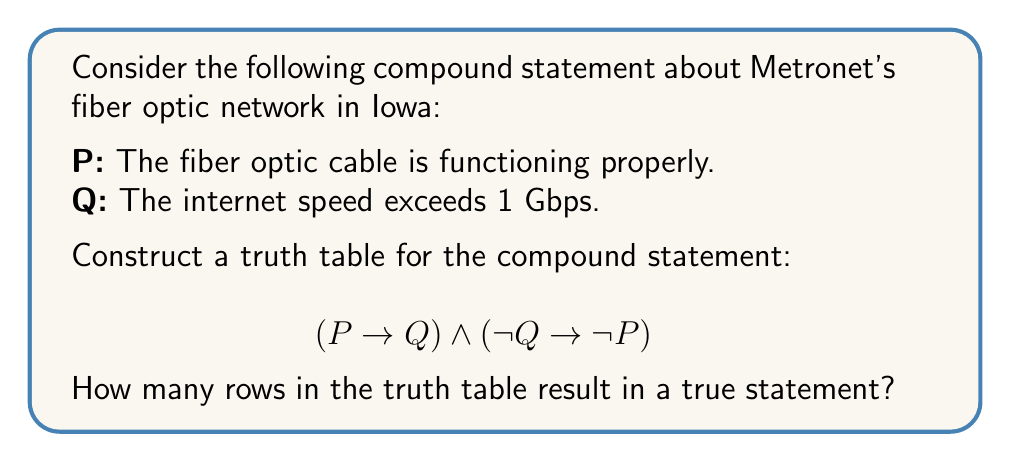Help me with this question. Let's approach this step-by-step:

1) First, we need to construct the truth table. We'll have columns for P, Q, $(P \rightarrow Q)$, $(\lnot Q \rightarrow \lnot P)$, and the final compound statement.

2) The truth table will have 4 rows (2^2 since we have 2 variables):

   | P | Q | $(P \rightarrow Q)$ | $(\lnot Q \rightarrow \lnot P)$ | $(P \rightarrow Q) \land (\lnot Q \rightarrow \lnot P)$ |
   |---|---|---------------------|--------------------------------|--------------------------------------------------------|
   | T | T |                     |                                |                                                        |
   | T | F |                     |                                |                                                        |
   | F | T |                     |                                |                                                        |
   | F | F |                     |                                |                                                        |

3) Now, let's fill in the $(P \rightarrow Q)$ column:
   - Remember, $P \rightarrow Q$ is false only when P is true and Q is false.

4) Next, let's fill in the $(\lnot Q \rightarrow \lnot P)$ column:
   - This is equivalent to $(Q \lor \lnot P)$

5) Finally, we'll compute the AND of these two columns:

   | P | Q | $(P \rightarrow Q)$ | $(\lnot Q \rightarrow \lnot P)$ | $(P \rightarrow Q) \land (\lnot Q \rightarrow \lnot P)$ |
   |---|---|---------------------|--------------------------------|--------------------------------------------------------|
   | T | T |         T           |              T                 |                        T                               |
   | T | F |         F           |              F                 |                        F                               |
   | F | T |         T           |              T                 |                        T                               |
   | F | F |         T           |              T                 |                        T                               |

6) Counting the number of true statements in the final column, we see that there are 3 rows that result in a true statement.
Answer: 3 